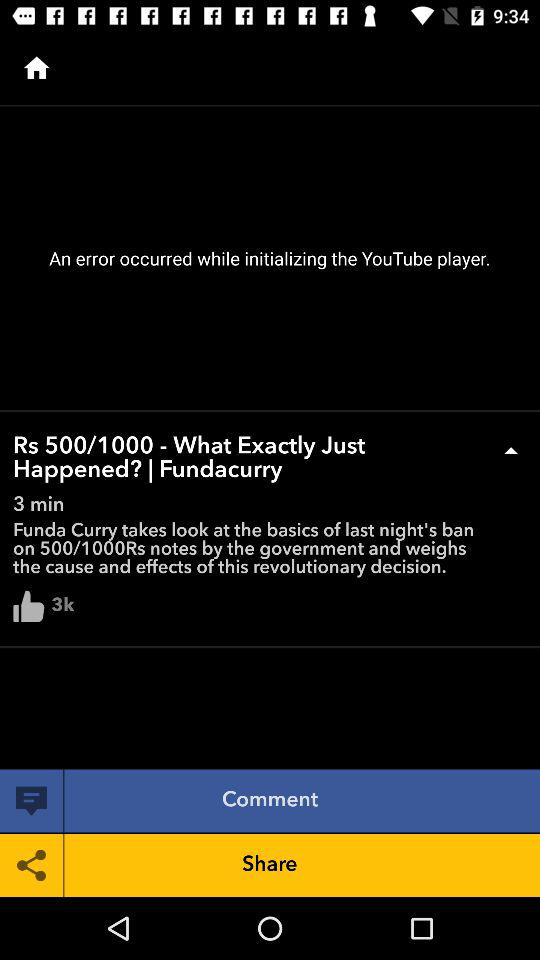What is the total number of likes? The total number of likes is 3k. 